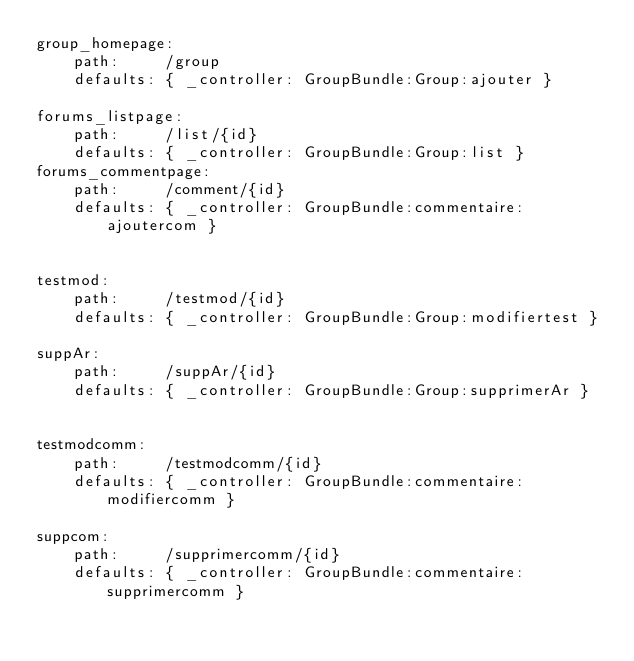Convert code to text. <code><loc_0><loc_0><loc_500><loc_500><_YAML_>group_homepage:
    path:     /group
    defaults: { _controller: GroupBundle:Group:ajouter }

forums_listpage:
    path:     /list/{id}
    defaults: { _controller: GroupBundle:Group:list }
forums_commentpage:
    path:     /comment/{id}
    defaults: { _controller: GroupBundle:commentaire:ajoutercom }


testmod:
    path:     /testmod/{id}
    defaults: { _controller: GroupBundle:Group:modifiertest }

suppAr:
    path:     /suppAr/{id}
    defaults: { _controller: GroupBundle:Group:supprimerAr }


testmodcomm:
    path:     /testmodcomm/{id}
    defaults: { _controller: GroupBundle:commentaire:modifiercomm }

suppcom:
    path:     /supprimercomm/{id}
    defaults: { _controller: GroupBundle:commentaire:supprimercomm }

</code> 